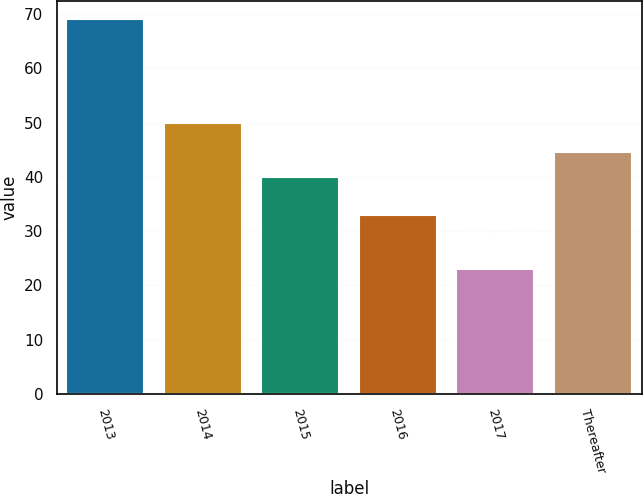Convert chart to OTSL. <chart><loc_0><loc_0><loc_500><loc_500><bar_chart><fcel>2013<fcel>2014<fcel>2015<fcel>2016<fcel>2017<fcel>Thereafter<nl><fcel>69<fcel>50<fcel>40<fcel>33<fcel>23<fcel>44.6<nl></chart> 